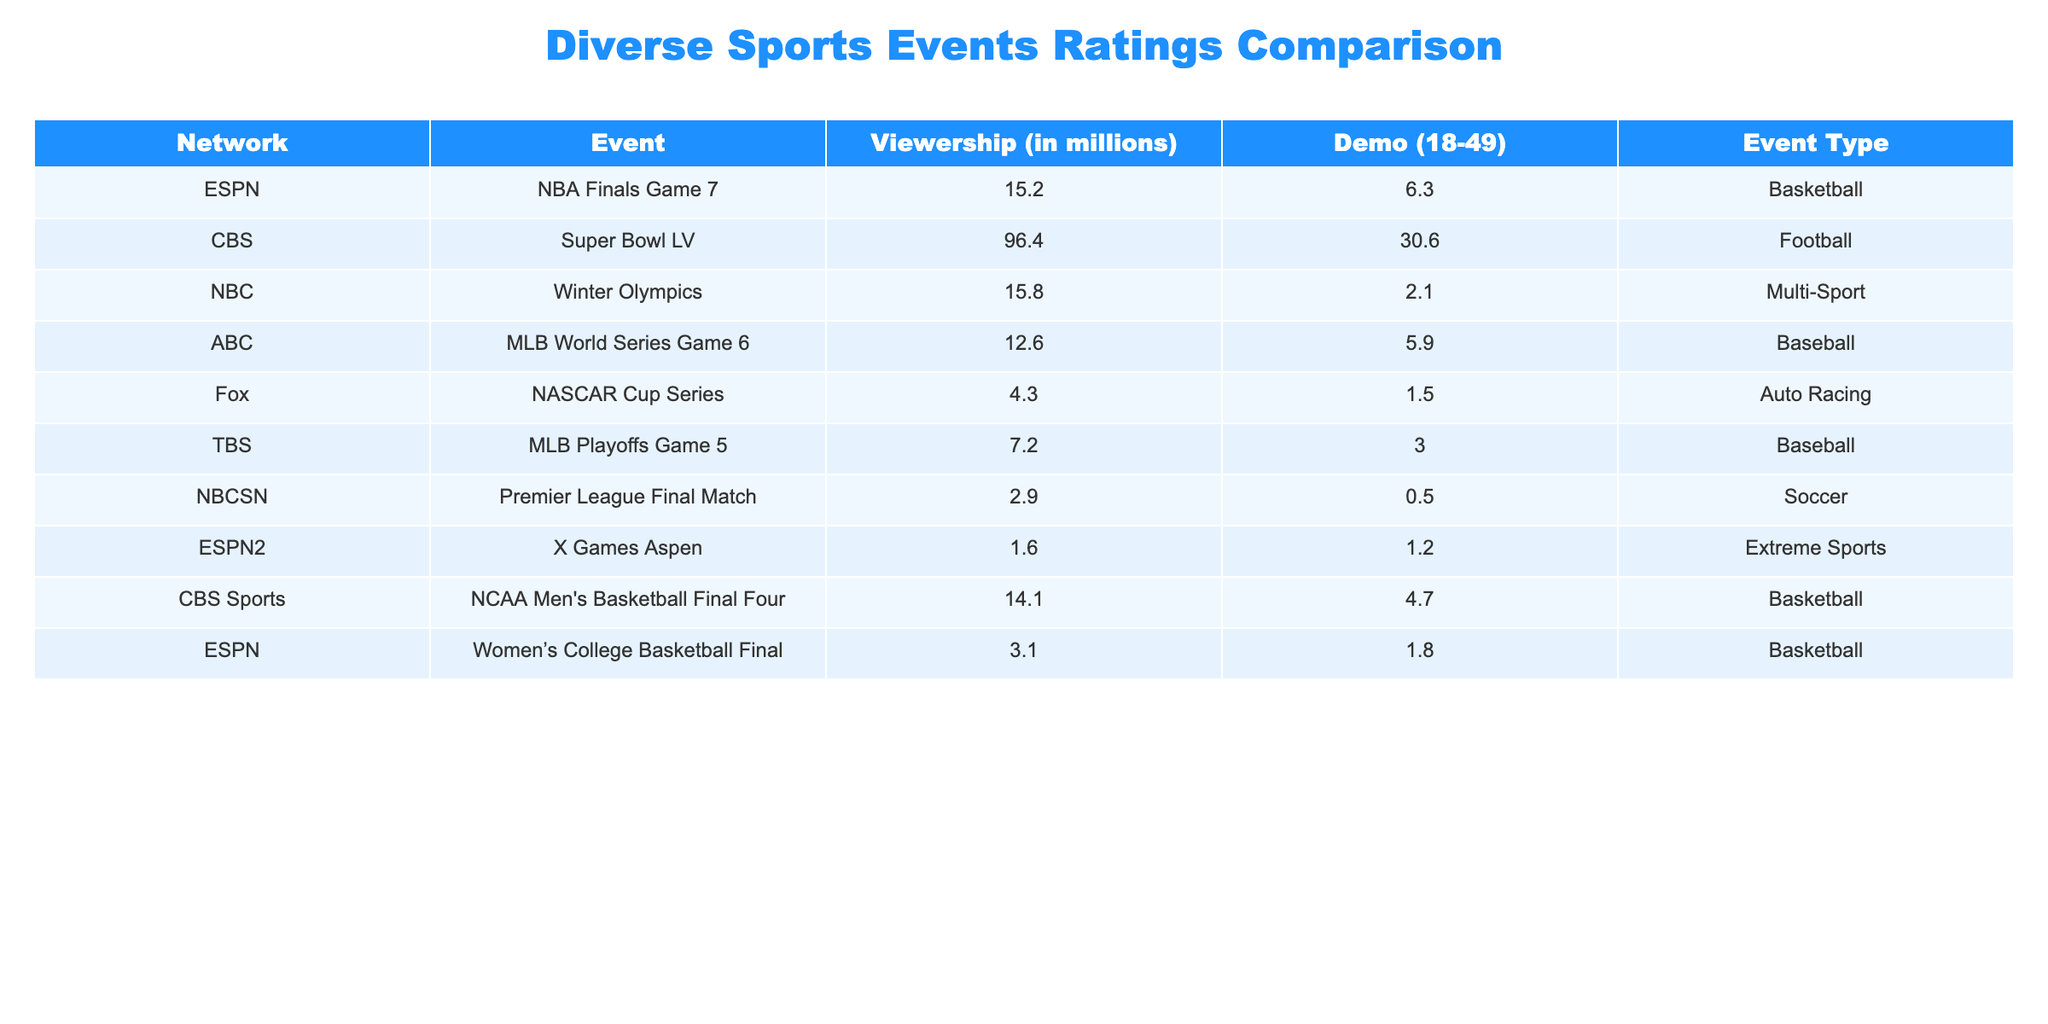What was the viewership for the Super Bowl LV? The table indicates that the viewership for the Super Bowl LV event was 96.4 million.
Answer: 96.4 million Which event had the highest Demo (18-49) rating? The highest Demo rating in the table belongs to the Super Bowl LV with a rating of 30.6.
Answer: 30.6 What is the average viewership for baseball events listed in the table? The baseball events are the MLB World Series Game 6 with 12.6 million and the MLB Playoffs Game 5 with 7.2 million. Adding these gives 19.8 million. Dividing by 2 events results in an average viewership of 9.9 million.
Answer: 9.9 million Has NASCAR ever reached a viewership higher than 10 million in this table? Looking at the NASCAR Cup Series, its viewership is 4.3 million, which is below 10 million. Therefore, the statement is false.
Answer: No What was the combined viewership for the Winter Olympics and the X Games Aspen? The viewership for the Winter Olympics is 15.8 million, and the X Games Aspen is 1.6 million, summing these gives a total viewership of 17.4 million.
Answer: 17.4 million Is the demo rating for the Women's College Basketball Final lower than 2.0? The demo rating for the Women's College Basketball Final is 1.8, which is lower than 2.0, so the statement is true.
Answer: Yes What type of sports event had the lowest viewership? Evaluating the viewership numbers, the event with the lowest viewership is the Premier League Final Match with 2.9 million.
Answer: Premier League Final Match How many sports events listed have a viewership of less than 5 million? Only the NASCAR Cup Series with 4.3 million and the X Games Aspen with 1.6 million are below 5 million, making a total of 2 events.
Answer: 2 events 